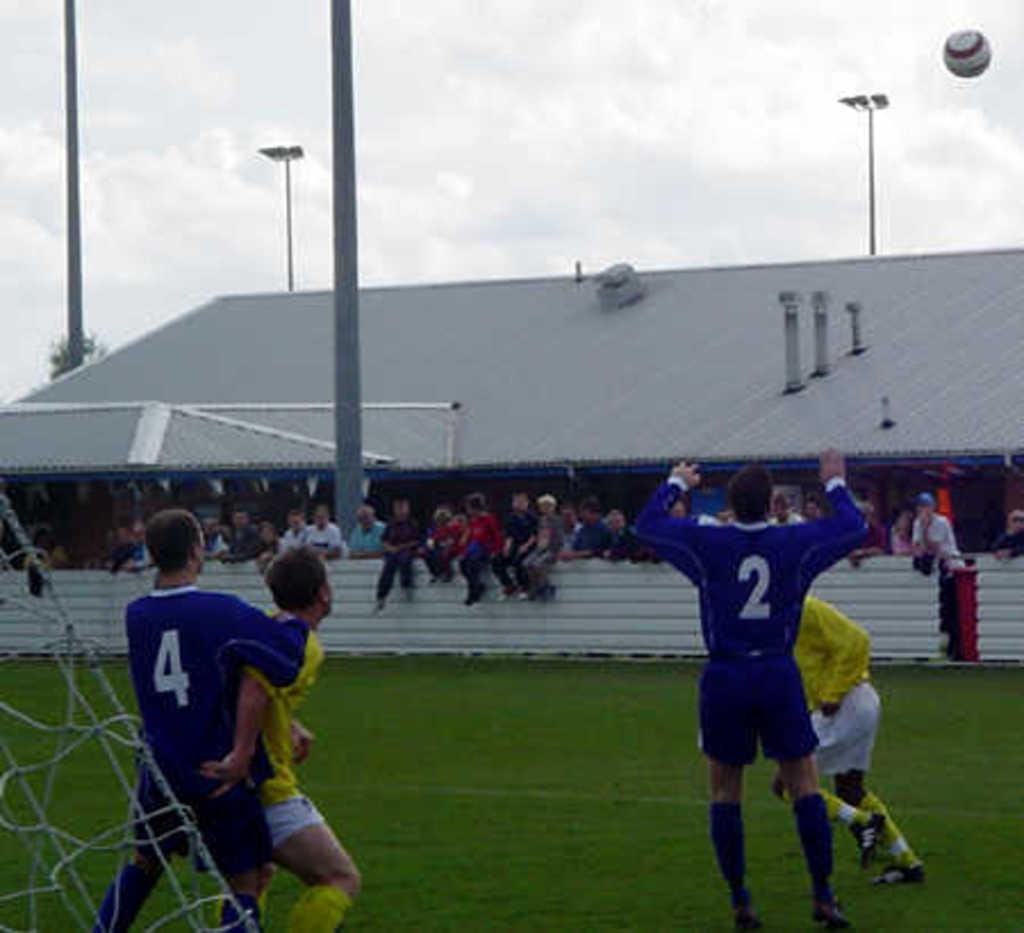What are the people in the image doing? There are people standing on the ground and sitting on a wall in the image. What can be seen in the background of the image? There is a building visible in the background of the image. What is happening in the sky in the image? A ball is flying in the sky in the image. What is the name of the person holding the crate in the image? There is no person holding a crate in the image. 